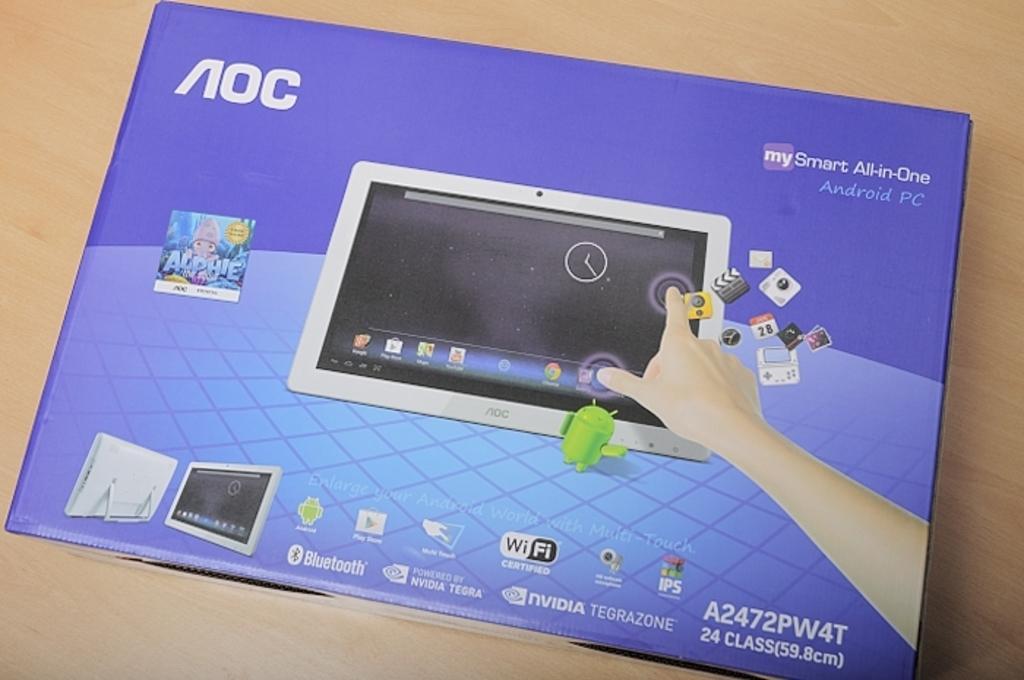In one or two sentences, can you explain what this image depicts? In the image we can see there is a box kept on the table. On the box there is a picture of an ipad and there is a hand of a person touching the screen of the ipad. It's written ¨AOC¨. 